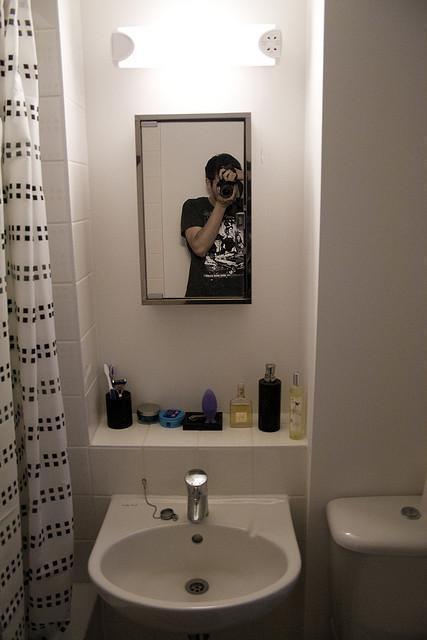How many toothbrushes are in the picture?
Give a very brief answer. 1. How many bottles of cologne are there?
Give a very brief answer. 3. How many motorcycles are parked off the street?
Give a very brief answer. 0. 